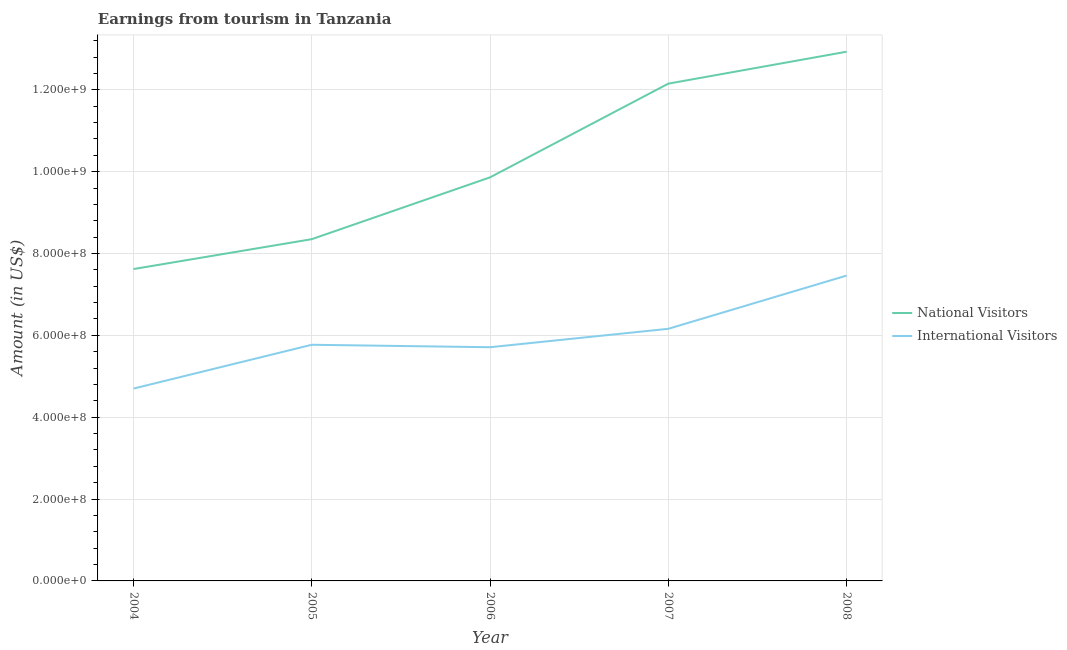Is the number of lines equal to the number of legend labels?
Give a very brief answer. Yes. What is the amount earned from international visitors in 2006?
Give a very brief answer. 5.71e+08. Across all years, what is the maximum amount earned from international visitors?
Ensure brevity in your answer.  7.46e+08. Across all years, what is the minimum amount earned from national visitors?
Keep it short and to the point. 7.62e+08. What is the total amount earned from international visitors in the graph?
Offer a very short reply. 2.98e+09. What is the difference between the amount earned from national visitors in 2004 and that in 2005?
Offer a terse response. -7.30e+07. What is the difference between the amount earned from international visitors in 2004 and the amount earned from national visitors in 2005?
Make the answer very short. -3.65e+08. What is the average amount earned from international visitors per year?
Provide a succinct answer. 5.96e+08. In the year 2007, what is the difference between the amount earned from international visitors and amount earned from national visitors?
Your answer should be compact. -5.99e+08. What is the ratio of the amount earned from national visitors in 2005 to that in 2006?
Provide a short and direct response. 0.85. What is the difference between the highest and the second highest amount earned from national visitors?
Offer a very short reply. 7.80e+07. What is the difference between the highest and the lowest amount earned from national visitors?
Provide a succinct answer. 5.31e+08. Does the amount earned from national visitors monotonically increase over the years?
Keep it short and to the point. Yes. Does the graph contain any zero values?
Provide a short and direct response. No. Does the graph contain grids?
Offer a terse response. Yes. Where does the legend appear in the graph?
Provide a succinct answer. Center right. How are the legend labels stacked?
Give a very brief answer. Vertical. What is the title of the graph?
Offer a terse response. Earnings from tourism in Tanzania. What is the label or title of the Y-axis?
Your answer should be very brief. Amount (in US$). What is the Amount (in US$) of National Visitors in 2004?
Your response must be concise. 7.62e+08. What is the Amount (in US$) of International Visitors in 2004?
Provide a short and direct response. 4.70e+08. What is the Amount (in US$) of National Visitors in 2005?
Offer a terse response. 8.35e+08. What is the Amount (in US$) in International Visitors in 2005?
Offer a very short reply. 5.77e+08. What is the Amount (in US$) of National Visitors in 2006?
Your answer should be very brief. 9.86e+08. What is the Amount (in US$) of International Visitors in 2006?
Provide a succinct answer. 5.71e+08. What is the Amount (in US$) of National Visitors in 2007?
Provide a short and direct response. 1.22e+09. What is the Amount (in US$) of International Visitors in 2007?
Your answer should be compact. 6.16e+08. What is the Amount (in US$) of National Visitors in 2008?
Give a very brief answer. 1.29e+09. What is the Amount (in US$) in International Visitors in 2008?
Your answer should be very brief. 7.46e+08. Across all years, what is the maximum Amount (in US$) of National Visitors?
Give a very brief answer. 1.29e+09. Across all years, what is the maximum Amount (in US$) in International Visitors?
Offer a terse response. 7.46e+08. Across all years, what is the minimum Amount (in US$) of National Visitors?
Make the answer very short. 7.62e+08. Across all years, what is the minimum Amount (in US$) of International Visitors?
Make the answer very short. 4.70e+08. What is the total Amount (in US$) of National Visitors in the graph?
Ensure brevity in your answer.  5.09e+09. What is the total Amount (in US$) in International Visitors in the graph?
Your response must be concise. 2.98e+09. What is the difference between the Amount (in US$) in National Visitors in 2004 and that in 2005?
Ensure brevity in your answer.  -7.30e+07. What is the difference between the Amount (in US$) of International Visitors in 2004 and that in 2005?
Keep it short and to the point. -1.07e+08. What is the difference between the Amount (in US$) of National Visitors in 2004 and that in 2006?
Keep it short and to the point. -2.24e+08. What is the difference between the Amount (in US$) of International Visitors in 2004 and that in 2006?
Make the answer very short. -1.01e+08. What is the difference between the Amount (in US$) in National Visitors in 2004 and that in 2007?
Provide a short and direct response. -4.53e+08. What is the difference between the Amount (in US$) in International Visitors in 2004 and that in 2007?
Offer a very short reply. -1.46e+08. What is the difference between the Amount (in US$) of National Visitors in 2004 and that in 2008?
Your answer should be very brief. -5.31e+08. What is the difference between the Amount (in US$) of International Visitors in 2004 and that in 2008?
Offer a very short reply. -2.76e+08. What is the difference between the Amount (in US$) of National Visitors in 2005 and that in 2006?
Make the answer very short. -1.51e+08. What is the difference between the Amount (in US$) of National Visitors in 2005 and that in 2007?
Your response must be concise. -3.80e+08. What is the difference between the Amount (in US$) in International Visitors in 2005 and that in 2007?
Keep it short and to the point. -3.90e+07. What is the difference between the Amount (in US$) of National Visitors in 2005 and that in 2008?
Give a very brief answer. -4.58e+08. What is the difference between the Amount (in US$) of International Visitors in 2005 and that in 2008?
Provide a short and direct response. -1.69e+08. What is the difference between the Amount (in US$) of National Visitors in 2006 and that in 2007?
Provide a succinct answer. -2.29e+08. What is the difference between the Amount (in US$) in International Visitors in 2006 and that in 2007?
Provide a short and direct response. -4.50e+07. What is the difference between the Amount (in US$) of National Visitors in 2006 and that in 2008?
Your answer should be very brief. -3.07e+08. What is the difference between the Amount (in US$) of International Visitors in 2006 and that in 2008?
Provide a short and direct response. -1.75e+08. What is the difference between the Amount (in US$) in National Visitors in 2007 and that in 2008?
Your answer should be very brief. -7.80e+07. What is the difference between the Amount (in US$) of International Visitors in 2007 and that in 2008?
Offer a terse response. -1.30e+08. What is the difference between the Amount (in US$) of National Visitors in 2004 and the Amount (in US$) of International Visitors in 2005?
Your answer should be very brief. 1.85e+08. What is the difference between the Amount (in US$) of National Visitors in 2004 and the Amount (in US$) of International Visitors in 2006?
Your response must be concise. 1.91e+08. What is the difference between the Amount (in US$) in National Visitors in 2004 and the Amount (in US$) in International Visitors in 2007?
Ensure brevity in your answer.  1.46e+08. What is the difference between the Amount (in US$) of National Visitors in 2004 and the Amount (in US$) of International Visitors in 2008?
Offer a terse response. 1.60e+07. What is the difference between the Amount (in US$) of National Visitors in 2005 and the Amount (in US$) of International Visitors in 2006?
Ensure brevity in your answer.  2.64e+08. What is the difference between the Amount (in US$) in National Visitors in 2005 and the Amount (in US$) in International Visitors in 2007?
Your answer should be very brief. 2.19e+08. What is the difference between the Amount (in US$) in National Visitors in 2005 and the Amount (in US$) in International Visitors in 2008?
Your response must be concise. 8.90e+07. What is the difference between the Amount (in US$) of National Visitors in 2006 and the Amount (in US$) of International Visitors in 2007?
Provide a short and direct response. 3.70e+08. What is the difference between the Amount (in US$) of National Visitors in 2006 and the Amount (in US$) of International Visitors in 2008?
Offer a terse response. 2.40e+08. What is the difference between the Amount (in US$) in National Visitors in 2007 and the Amount (in US$) in International Visitors in 2008?
Keep it short and to the point. 4.69e+08. What is the average Amount (in US$) of National Visitors per year?
Make the answer very short. 1.02e+09. What is the average Amount (in US$) of International Visitors per year?
Your answer should be compact. 5.96e+08. In the year 2004, what is the difference between the Amount (in US$) in National Visitors and Amount (in US$) in International Visitors?
Ensure brevity in your answer.  2.92e+08. In the year 2005, what is the difference between the Amount (in US$) of National Visitors and Amount (in US$) of International Visitors?
Provide a short and direct response. 2.58e+08. In the year 2006, what is the difference between the Amount (in US$) in National Visitors and Amount (in US$) in International Visitors?
Offer a very short reply. 4.15e+08. In the year 2007, what is the difference between the Amount (in US$) of National Visitors and Amount (in US$) of International Visitors?
Provide a short and direct response. 5.99e+08. In the year 2008, what is the difference between the Amount (in US$) in National Visitors and Amount (in US$) in International Visitors?
Your answer should be very brief. 5.47e+08. What is the ratio of the Amount (in US$) in National Visitors in 2004 to that in 2005?
Your response must be concise. 0.91. What is the ratio of the Amount (in US$) in International Visitors in 2004 to that in 2005?
Your answer should be very brief. 0.81. What is the ratio of the Amount (in US$) of National Visitors in 2004 to that in 2006?
Provide a succinct answer. 0.77. What is the ratio of the Amount (in US$) in International Visitors in 2004 to that in 2006?
Ensure brevity in your answer.  0.82. What is the ratio of the Amount (in US$) in National Visitors in 2004 to that in 2007?
Give a very brief answer. 0.63. What is the ratio of the Amount (in US$) of International Visitors in 2004 to that in 2007?
Offer a terse response. 0.76. What is the ratio of the Amount (in US$) of National Visitors in 2004 to that in 2008?
Offer a very short reply. 0.59. What is the ratio of the Amount (in US$) of International Visitors in 2004 to that in 2008?
Give a very brief answer. 0.63. What is the ratio of the Amount (in US$) in National Visitors in 2005 to that in 2006?
Your answer should be compact. 0.85. What is the ratio of the Amount (in US$) of International Visitors in 2005 to that in 2006?
Provide a short and direct response. 1.01. What is the ratio of the Amount (in US$) in National Visitors in 2005 to that in 2007?
Provide a short and direct response. 0.69. What is the ratio of the Amount (in US$) in International Visitors in 2005 to that in 2007?
Your answer should be very brief. 0.94. What is the ratio of the Amount (in US$) in National Visitors in 2005 to that in 2008?
Give a very brief answer. 0.65. What is the ratio of the Amount (in US$) in International Visitors in 2005 to that in 2008?
Ensure brevity in your answer.  0.77. What is the ratio of the Amount (in US$) in National Visitors in 2006 to that in 2007?
Provide a succinct answer. 0.81. What is the ratio of the Amount (in US$) of International Visitors in 2006 to that in 2007?
Keep it short and to the point. 0.93. What is the ratio of the Amount (in US$) in National Visitors in 2006 to that in 2008?
Keep it short and to the point. 0.76. What is the ratio of the Amount (in US$) of International Visitors in 2006 to that in 2008?
Your response must be concise. 0.77. What is the ratio of the Amount (in US$) in National Visitors in 2007 to that in 2008?
Your answer should be very brief. 0.94. What is the ratio of the Amount (in US$) in International Visitors in 2007 to that in 2008?
Make the answer very short. 0.83. What is the difference between the highest and the second highest Amount (in US$) in National Visitors?
Your answer should be very brief. 7.80e+07. What is the difference between the highest and the second highest Amount (in US$) in International Visitors?
Offer a terse response. 1.30e+08. What is the difference between the highest and the lowest Amount (in US$) in National Visitors?
Ensure brevity in your answer.  5.31e+08. What is the difference between the highest and the lowest Amount (in US$) of International Visitors?
Your answer should be compact. 2.76e+08. 